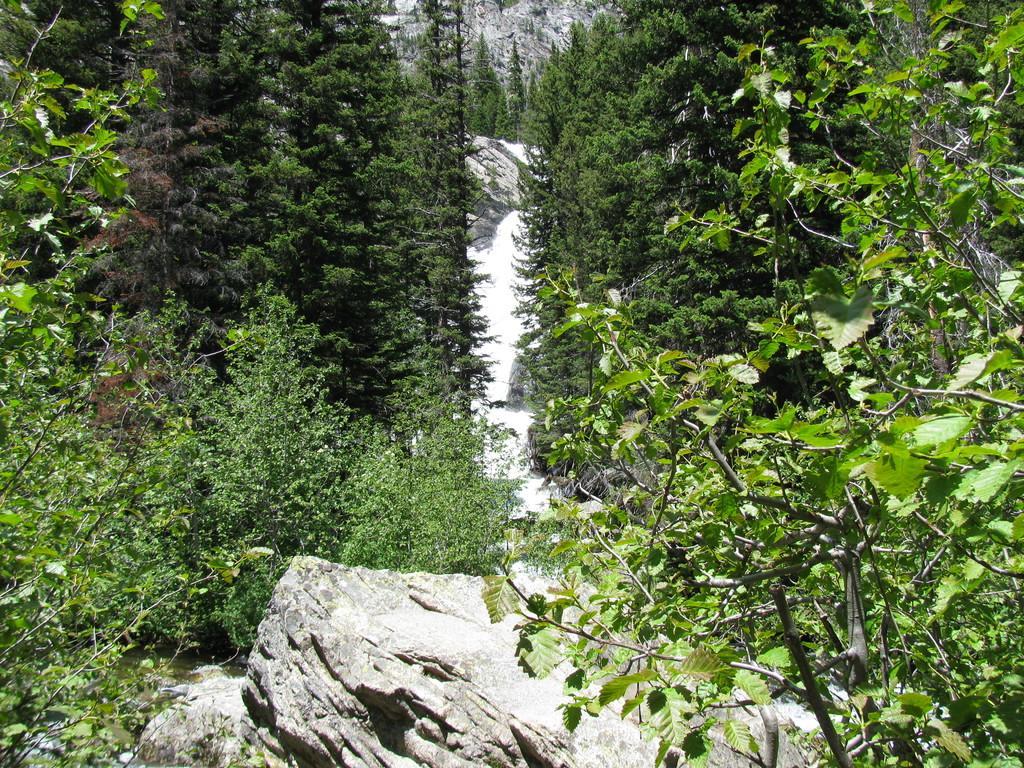Can you describe this image briefly? In this picture we can see a few rocks, trees, some plants and trees in the background. 